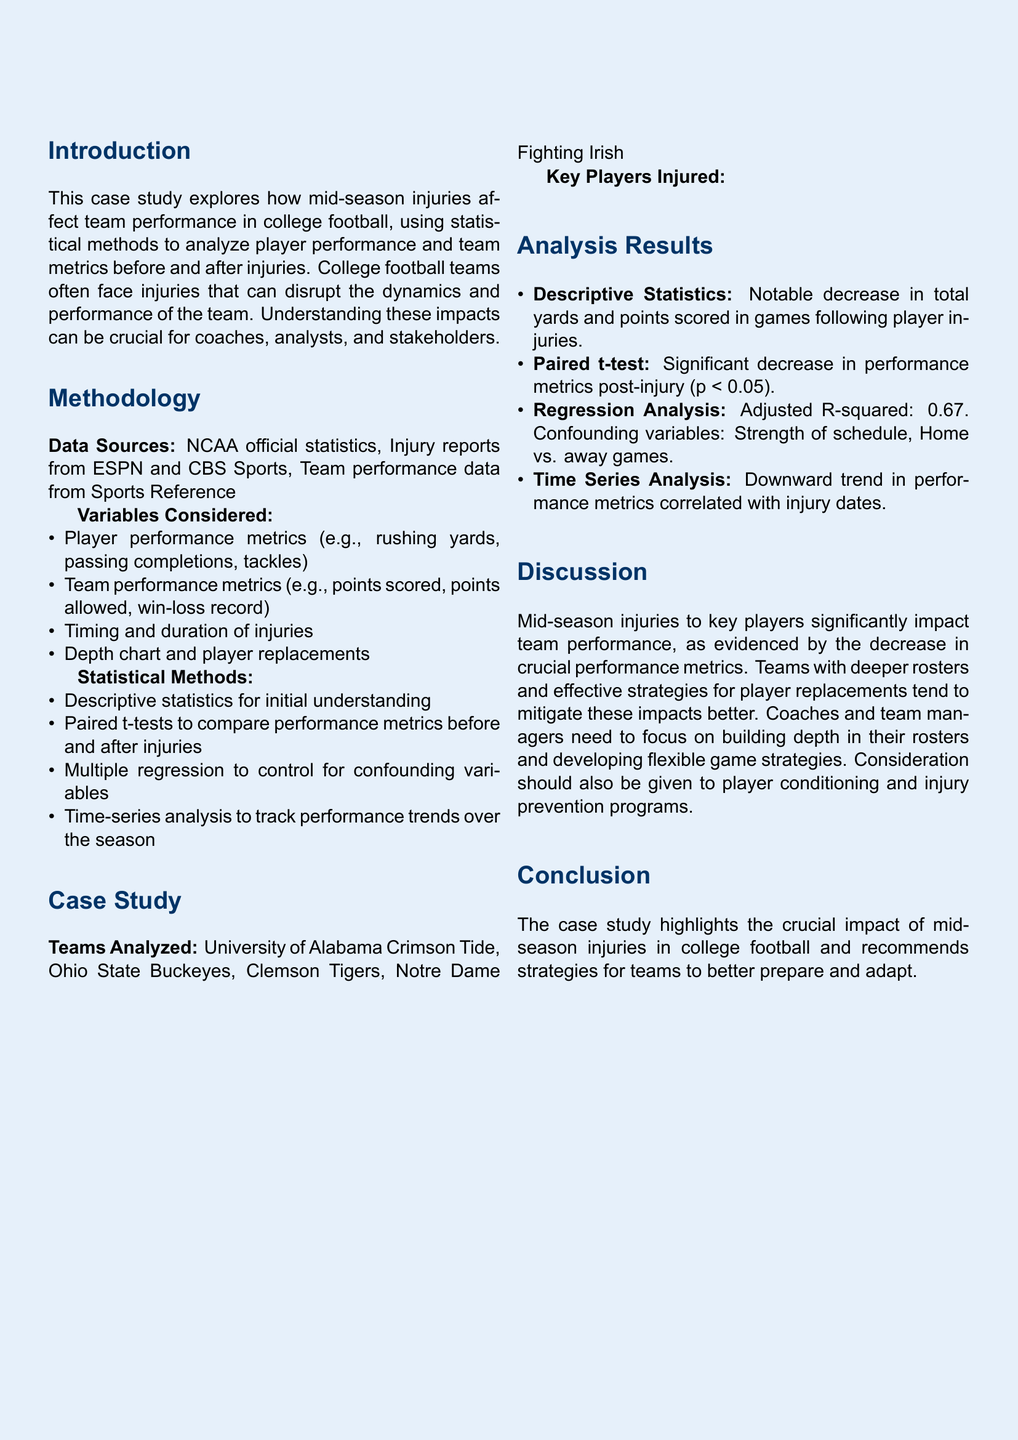what is the title of the case study? The title is stated in the beginning section of the document.
Answer: Impact of Mid-Season Injuries on Team Performance in College Football: A Multivariate Case Study which teams were analyzed in the case study? The teams analyzed are listed in the 'Case Study' section of the document.
Answer: University of Alabama Crimson Tide, Ohio State Buckeyes, Clemson Tigers, Notre Dame Fighting Irish what type of injury did Justin Fields have? The specific injury for Justin Fields is mentioned in the table of key players injured.
Answer: MCL sprain what statistical method was used to compare performance metrics before and after injuries? The methodology section explains the statistical method used for this comparison.
Answer: Paired t-tests what was the adjusted R-squared value from the regression analysis? The results from the analysis include the adjusted R-squared value, found in the 'Analysis Results' section.
Answer: 0.67 what is one recommended strategy for teams to adopt based on the findings? The discussion section provides recommendations for teams affected by injuries.
Answer: Building depth in their rosters what is the color scheme used in the document? The color scheme can be inferred from the color settings defined in the document.
Answer: Main blue and light blue what was one notable impact observed after player injuries? The impact observed is mentioned in the descriptive statistics in the analysis results.
Answer: Decrease in total yards and points scored 